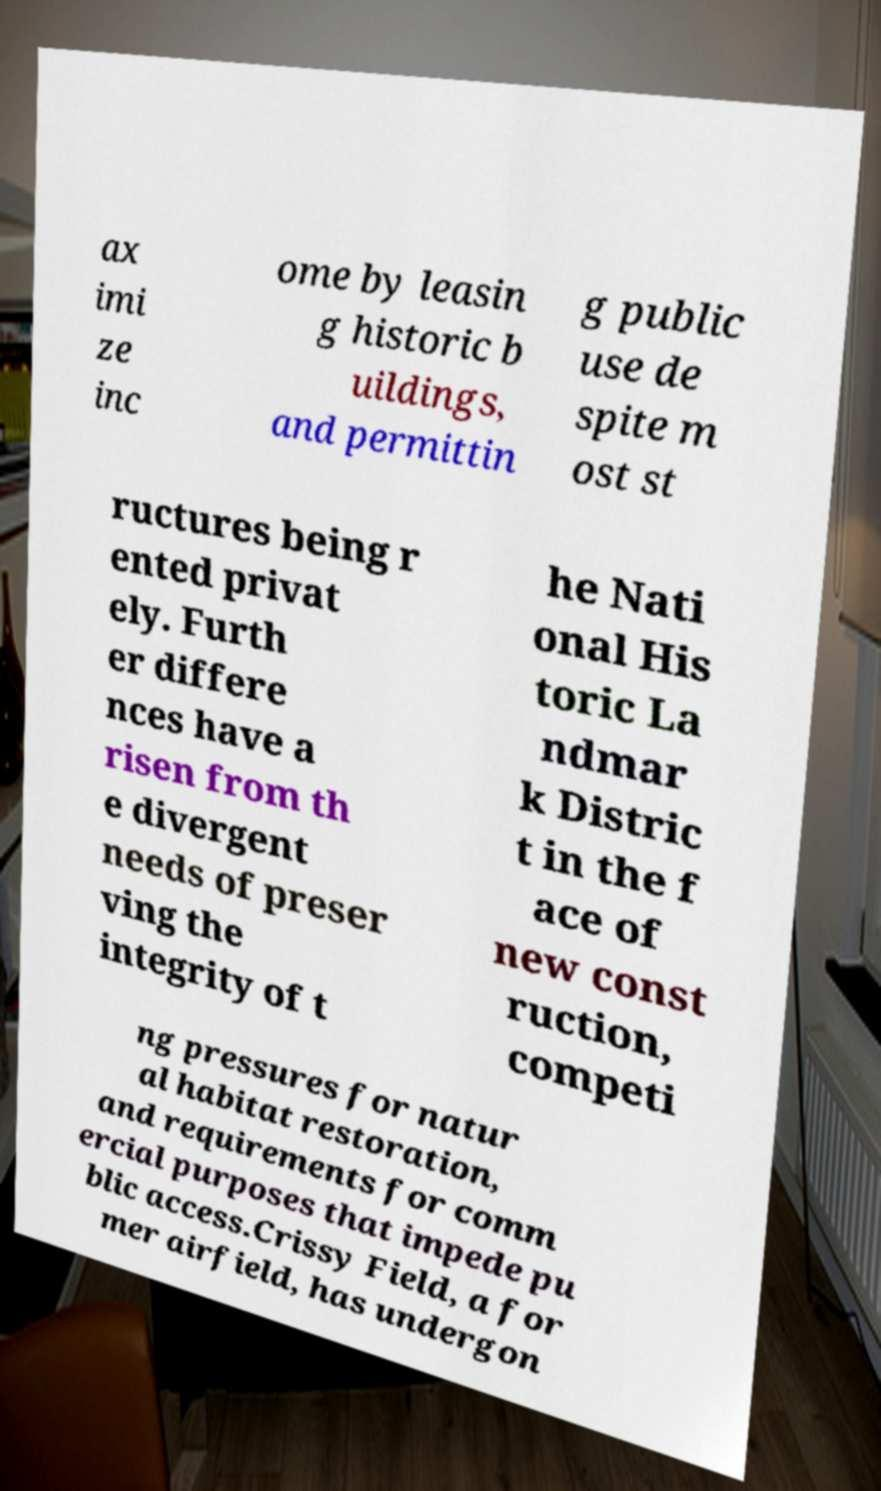Please identify and transcribe the text found in this image. ax imi ze inc ome by leasin g historic b uildings, and permittin g public use de spite m ost st ructures being r ented privat ely. Furth er differe nces have a risen from th e divergent needs of preser ving the integrity of t he Nati onal His toric La ndmar k Distric t in the f ace of new const ruction, competi ng pressures for natur al habitat restoration, and requirements for comm ercial purposes that impede pu blic access.Crissy Field, a for mer airfield, has undergon 